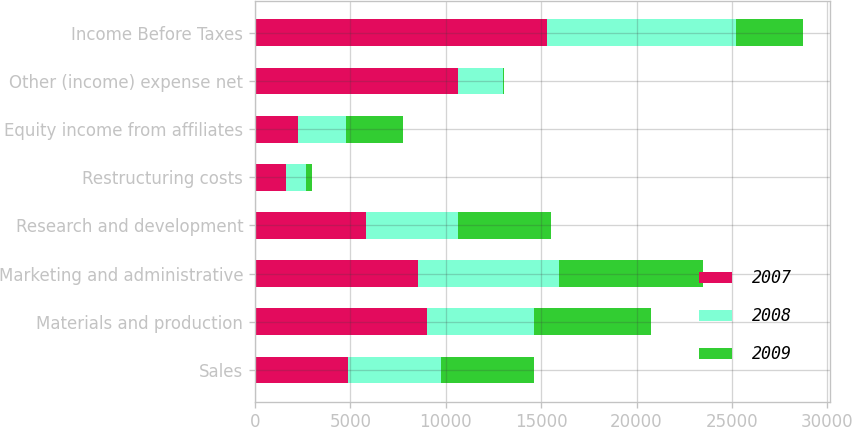<chart> <loc_0><loc_0><loc_500><loc_500><stacked_bar_chart><ecel><fcel>Sales<fcel>Materials and production<fcel>Marketing and administrative<fcel>Research and development<fcel>Restructuring costs<fcel>Equity income from affiliates<fcel>Other (income) expense net<fcel>Income Before Taxes<nl><fcel>2007<fcel>4882.8<fcel>9018.9<fcel>8543.2<fcel>5845<fcel>1633.9<fcel>2235<fcel>10669.5<fcel>15291.8<nl><fcel>2008<fcel>4882.8<fcel>5582.5<fcel>7377<fcel>4805.3<fcel>1032.5<fcel>2560.6<fcel>2318.1<fcel>9931.7<nl><fcel>2009<fcel>4882.8<fcel>6140.7<fcel>7556.7<fcel>4882.8<fcel>327.1<fcel>2976.5<fcel>75.2<fcel>3492.1<nl></chart> 